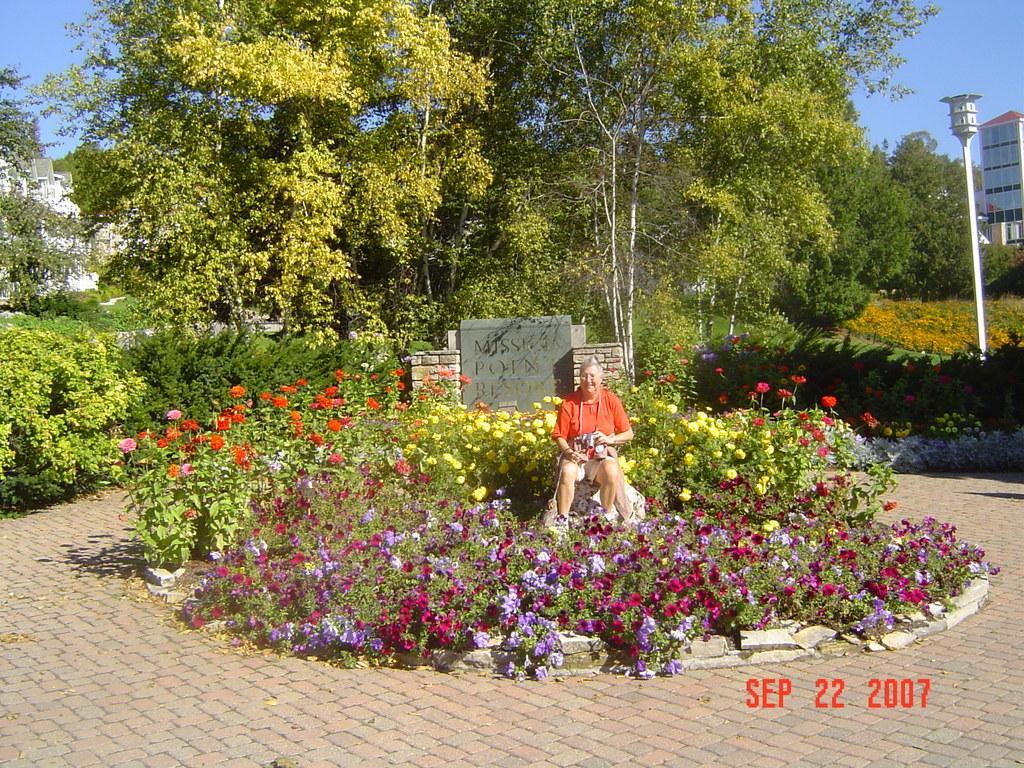How would you summarize this image in a sentence or two? In this picture I can see trees, buildings and I can see pole light and I can see few plants and flowers and I can see women sitting and she is holding something in her hands and I can see text on the stone and I can see text at the bottom right corner of the picture and I can see a blue sky. 